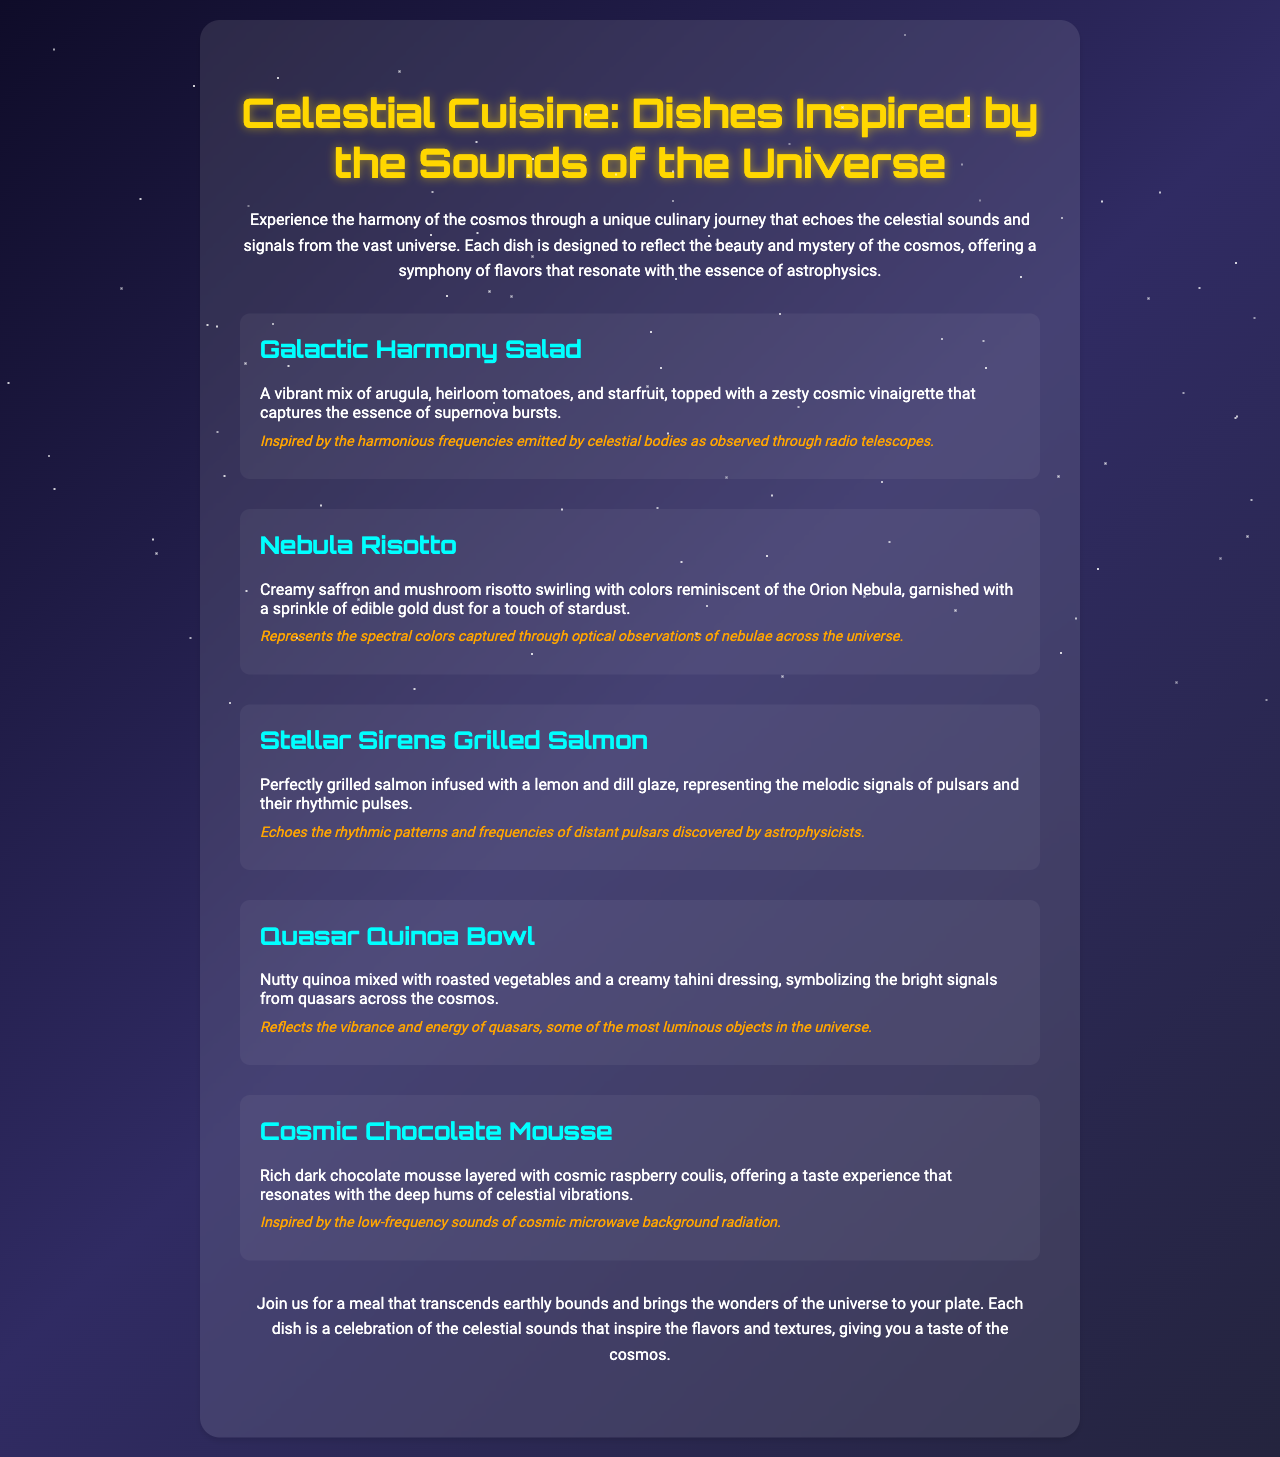what is the title of the menu? The title of the menu is presented prominently at the top of the document, under the heading.
Answer: Celestial Cuisine: Dishes Inspired by the Sounds of the Universe how many dishes are listed in the document? The document contains a section where all the dishes are mentioned, and by counting them, we find the total.
Answer: Five which dish is inspired by pulsars? The dish description mentions connections to the melodic signals of pulsars, making it identifiable.
Answer: Stellar Sirens Grilled Salmon what ingredient is in the Galactic Harmony Salad? The dish description lists the specific ingredients that are part of this salad.
Answer: Arugula what is the main theme of the menu? The document presents an introductory overview that encapsulates the overall theme.
Answer: Celestial sounds and signals which dish features edible gold dust? The dish description specifically mentions the inclusion of this luxurious element.
Answer: Nebula Risotto which dessert resonates with cosmic vibrations? The description of a dessert directly correlates it with celestial vibrations, allowing us to identify it.
Answer: Cosmic Chocolate Mousse what color theme is used in the menu's background? A description is provided in the document detailing the color gradient of the background.
Answer: Gradient of dark colors what is the inspiration behind the Quasar Quinoa Bowl? The dish description indicates the source of inspiration related to astronomical objects.
Answer: Bright signals from quasars 